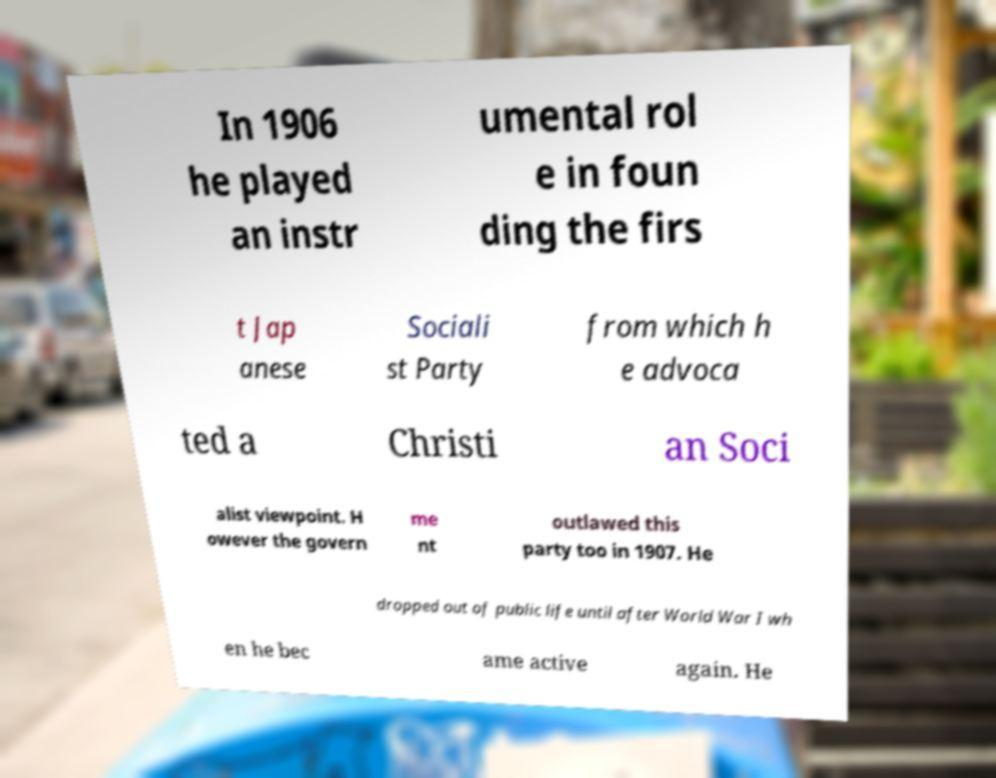There's text embedded in this image that I need extracted. Can you transcribe it verbatim? In 1906 he played an instr umental rol e in foun ding the firs t Jap anese Sociali st Party from which h e advoca ted a Christi an Soci alist viewpoint. H owever the govern me nt outlawed this party too in 1907. He dropped out of public life until after World War I wh en he bec ame active again. He 